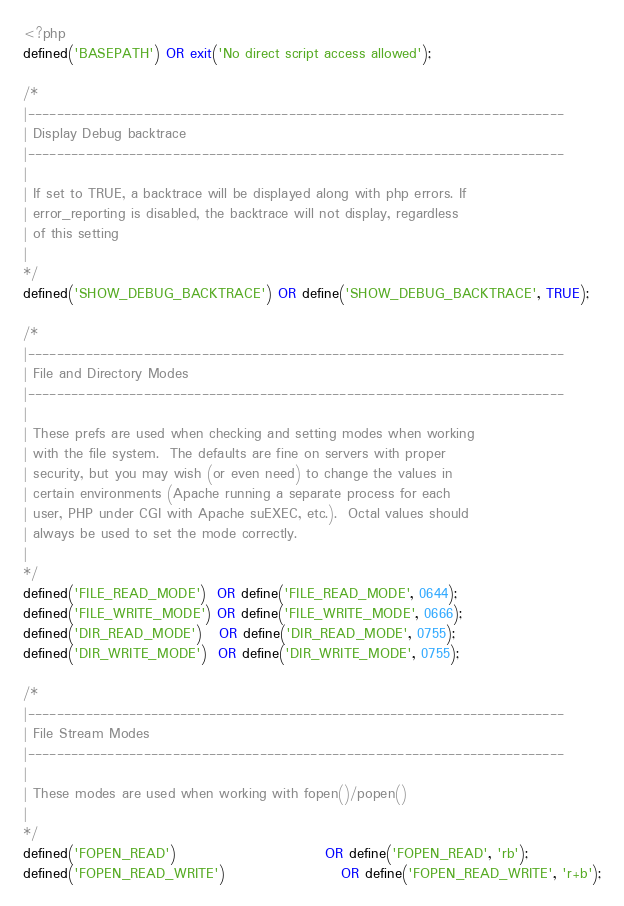Convert code to text. <code><loc_0><loc_0><loc_500><loc_500><_PHP_><?php
defined('BASEPATH') OR exit('No direct script access allowed');

/*
|--------------------------------------------------------------------------
| Display Debug backtrace
|--------------------------------------------------------------------------
|
| If set to TRUE, a backtrace will be displayed along with php errors. If
| error_reporting is disabled, the backtrace will not display, regardless
| of this setting
|
*/
defined('SHOW_DEBUG_BACKTRACE') OR define('SHOW_DEBUG_BACKTRACE', TRUE);

/*
|--------------------------------------------------------------------------
| File and Directory Modes
|--------------------------------------------------------------------------
|
| These prefs are used when checking and setting modes when working
| with the file system.  The defaults are fine on servers with proper
| security, but you may wish (or even need) to change the values in
| certain environments (Apache running a separate process for each
| user, PHP under CGI with Apache suEXEC, etc.).  Octal values should
| always be used to set the mode correctly.
|
*/
defined('FILE_READ_MODE')  OR define('FILE_READ_MODE', 0644);
defined('FILE_WRITE_MODE') OR define('FILE_WRITE_MODE', 0666);
defined('DIR_READ_MODE')   OR define('DIR_READ_MODE', 0755);
defined('DIR_WRITE_MODE')  OR define('DIR_WRITE_MODE', 0755);

/*
|--------------------------------------------------------------------------
| File Stream Modes
|--------------------------------------------------------------------------
|
| These modes are used when working with fopen()/popen()
|
*/
defined('FOPEN_READ')                           OR define('FOPEN_READ', 'rb');
defined('FOPEN_READ_WRITE')                     OR define('FOPEN_READ_WRITE', 'r+b');</code> 